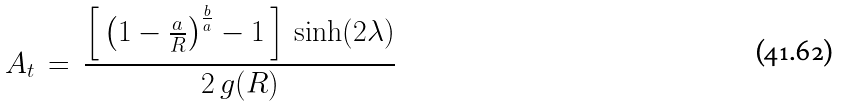Convert formula to latex. <formula><loc_0><loc_0><loc_500><loc_500>A _ { t } \, = \, \frac { \left [ \, { \left ( 1 - \frac { a } { R } \right ) } ^ { \frac { b } { a } } - 1 \, \right ] \, \sinh ( 2 \lambda ) } { 2 \, g ( R ) }</formula> 